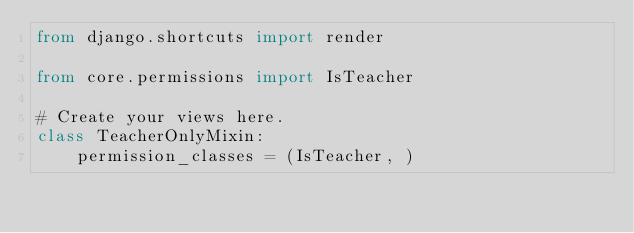Convert code to text. <code><loc_0><loc_0><loc_500><loc_500><_Python_>from django.shortcuts import render

from core.permissions import IsTeacher

# Create your views here.
class TeacherOnlyMixin:
    permission_classes = (IsTeacher, )</code> 